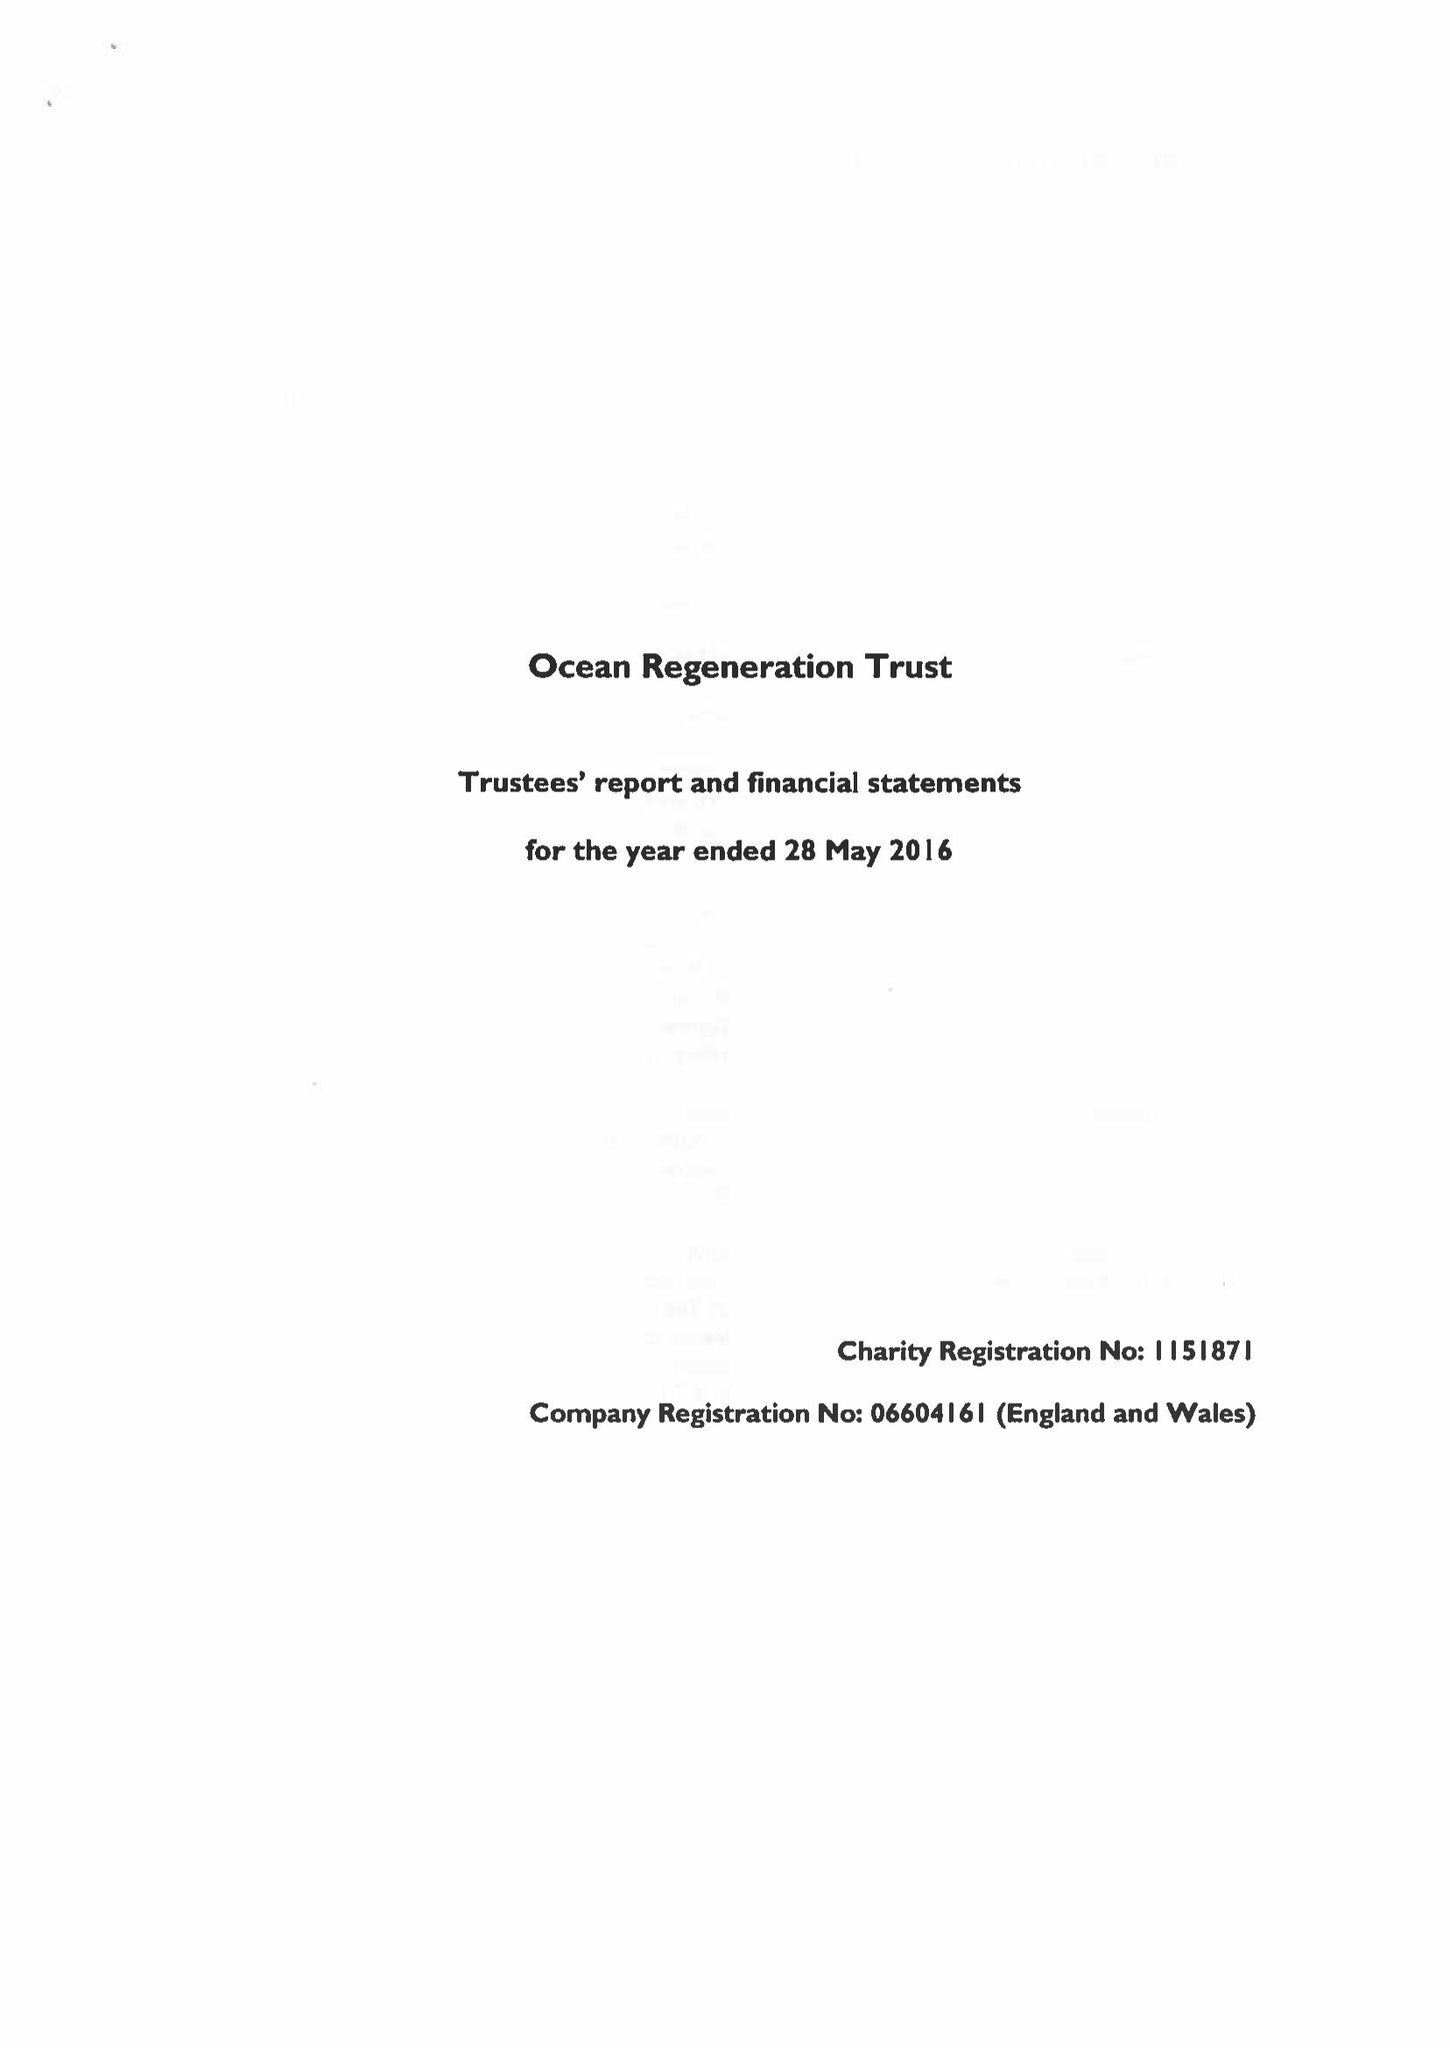What is the value for the address__postcode?
Answer the question using a single word or phrase. E1 4FG 